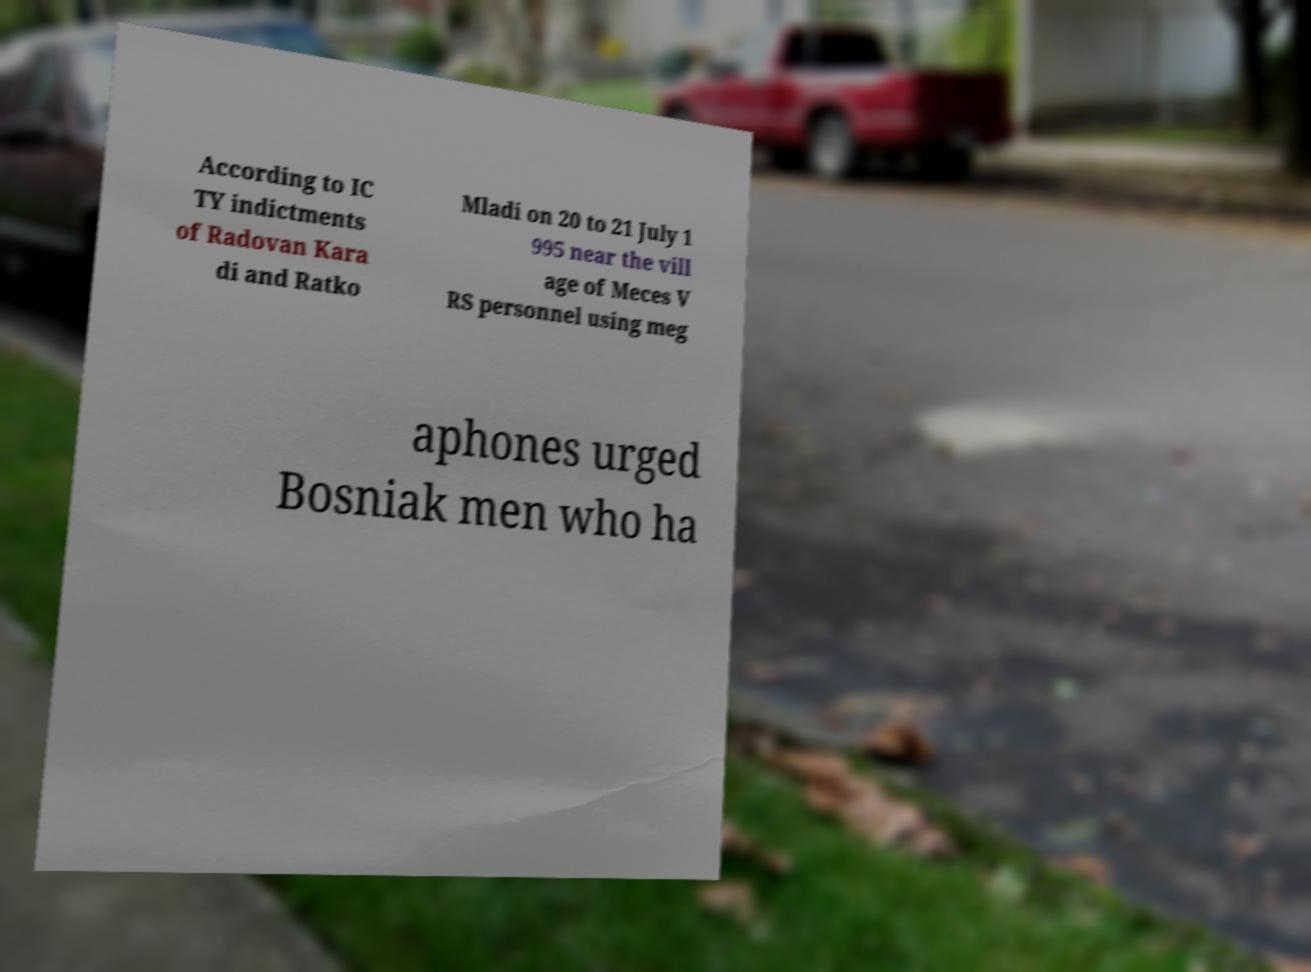Could you extract and type out the text from this image? According to IC TY indictments of Radovan Kara di and Ratko Mladi on 20 to 21 July 1 995 near the vill age of Meces V RS personnel using meg aphones urged Bosniak men who ha 